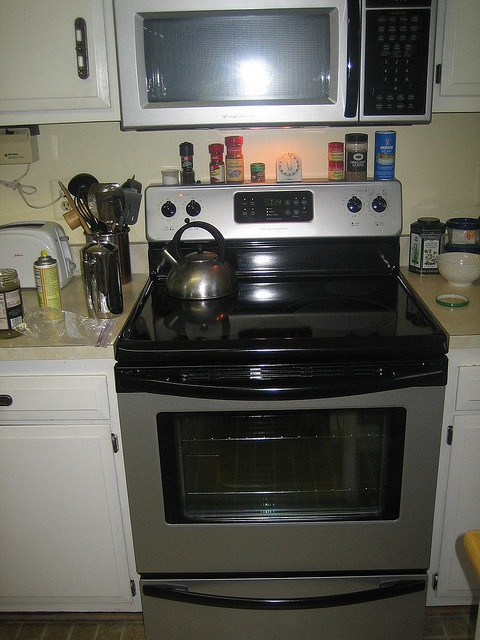Describe the objects in this image and their specific colors. I can see oven in gray, black, and darkgray tones, microwave in gray, black, darkgray, and lightgray tones, bowl in gray tones, spoon in gray, black, and darkgreen tones, and spoon in gray, black, and darkgreen tones in this image. 